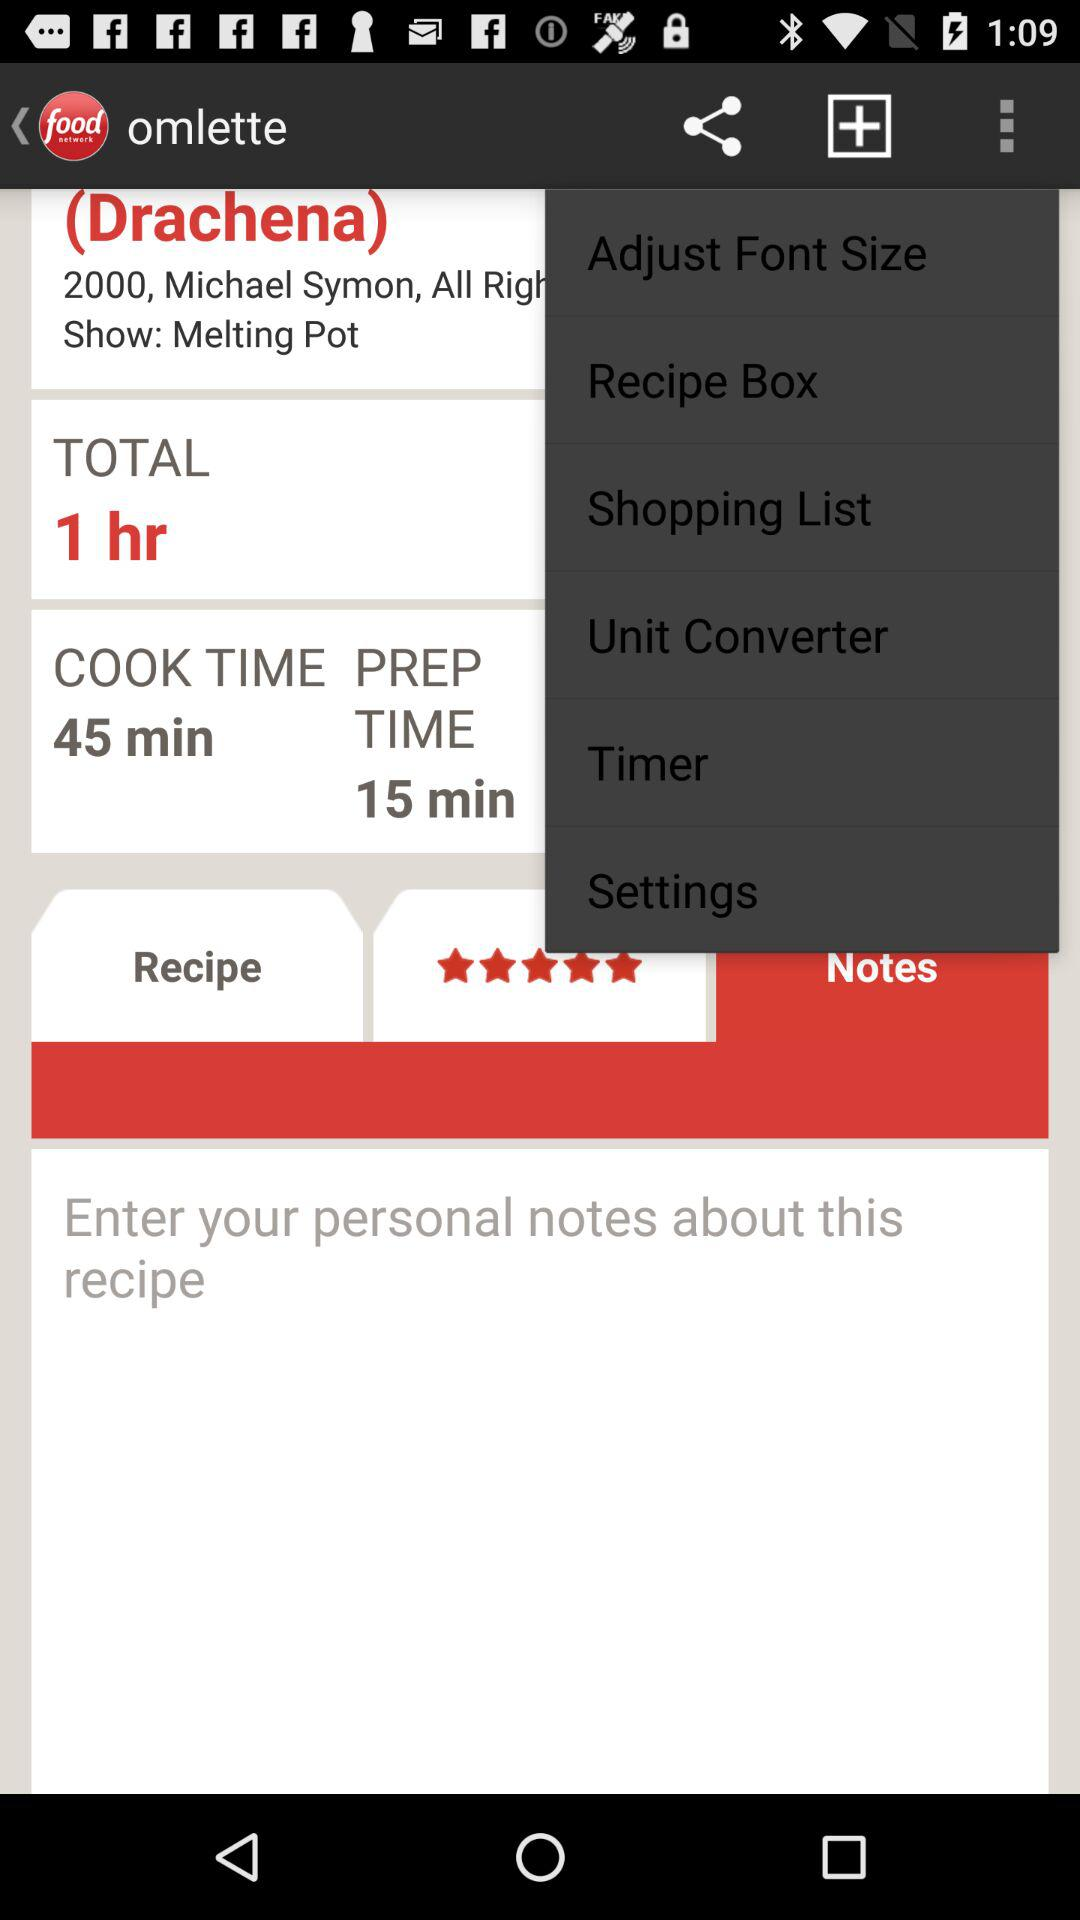How many more minutes is the cook time than the prep time?
Answer the question using a single word or phrase. 30 